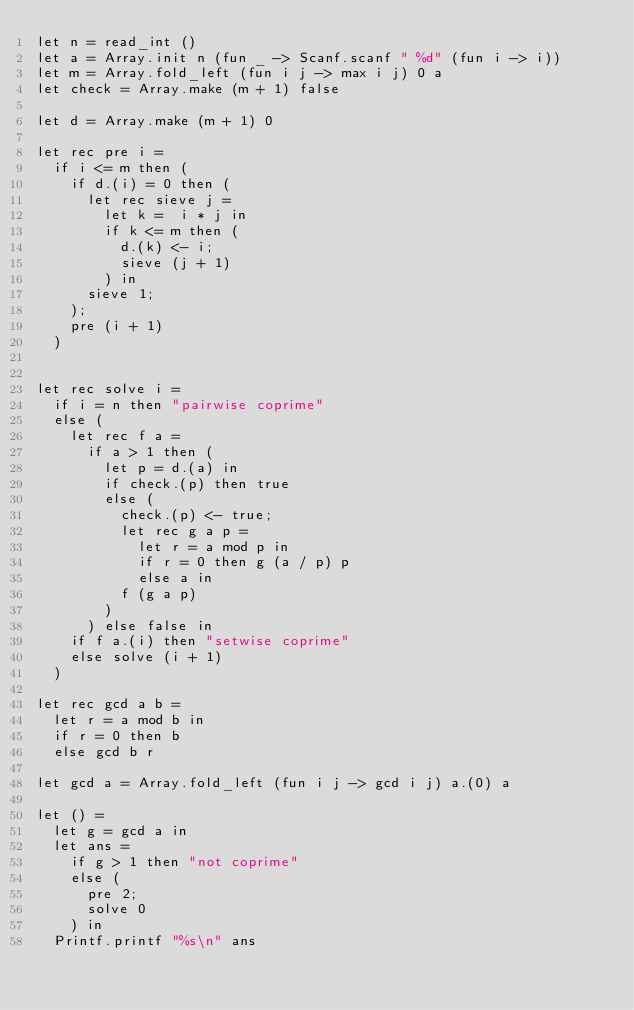<code> <loc_0><loc_0><loc_500><loc_500><_OCaml_>let n = read_int ()
let a = Array.init n (fun _ -> Scanf.scanf " %d" (fun i -> i))
let m = Array.fold_left (fun i j -> max i j) 0 a
let check = Array.make (m + 1) false

let d = Array.make (m + 1) 0

let rec pre i =
  if i <= m then (
    if d.(i) = 0 then (
      let rec sieve j =
        let k =  i * j in
        if k <= m then (
          d.(k) <- i;
          sieve (j + 1)
        ) in
      sieve 1;
    );
    pre (i + 1)
  )


let rec solve i =
  if i = n then "pairwise coprime"
  else (
    let rec f a =
      if a > 1 then (
        let p = d.(a) in
        if check.(p) then true
        else (
          check.(p) <- true;
          let rec g a p =
            let r = a mod p in
            if r = 0 then g (a / p) p
            else a in
          f (g a p)
        )
      ) else false in
    if f a.(i) then "setwise coprime"
    else solve (i + 1)
  )

let rec gcd a b =
  let r = a mod b in
  if r = 0 then b
  else gcd b r

let gcd a = Array.fold_left (fun i j -> gcd i j) a.(0) a

let () =
  let g = gcd a in
  let ans =
    if g > 1 then "not coprime"
    else (
      pre 2;
      solve 0
    ) in
  Printf.printf "%s\n" ans
</code> 